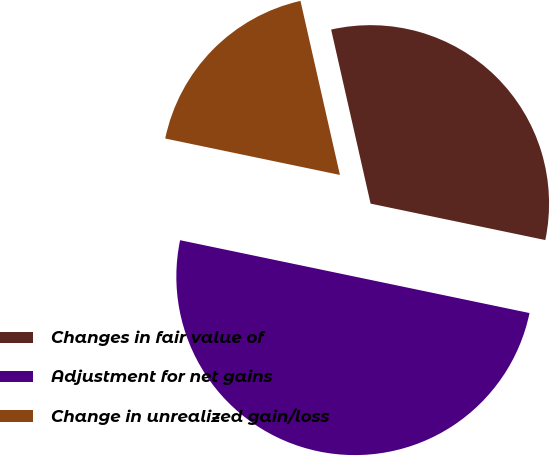Convert chart. <chart><loc_0><loc_0><loc_500><loc_500><pie_chart><fcel>Changes in fair value of<fcel>Adjustment for net gains<fcel>Change in unrealized gain/loss<nl><fcel>31.82%<fcel>50.0%<fcel>18.18%<nl></chart> 